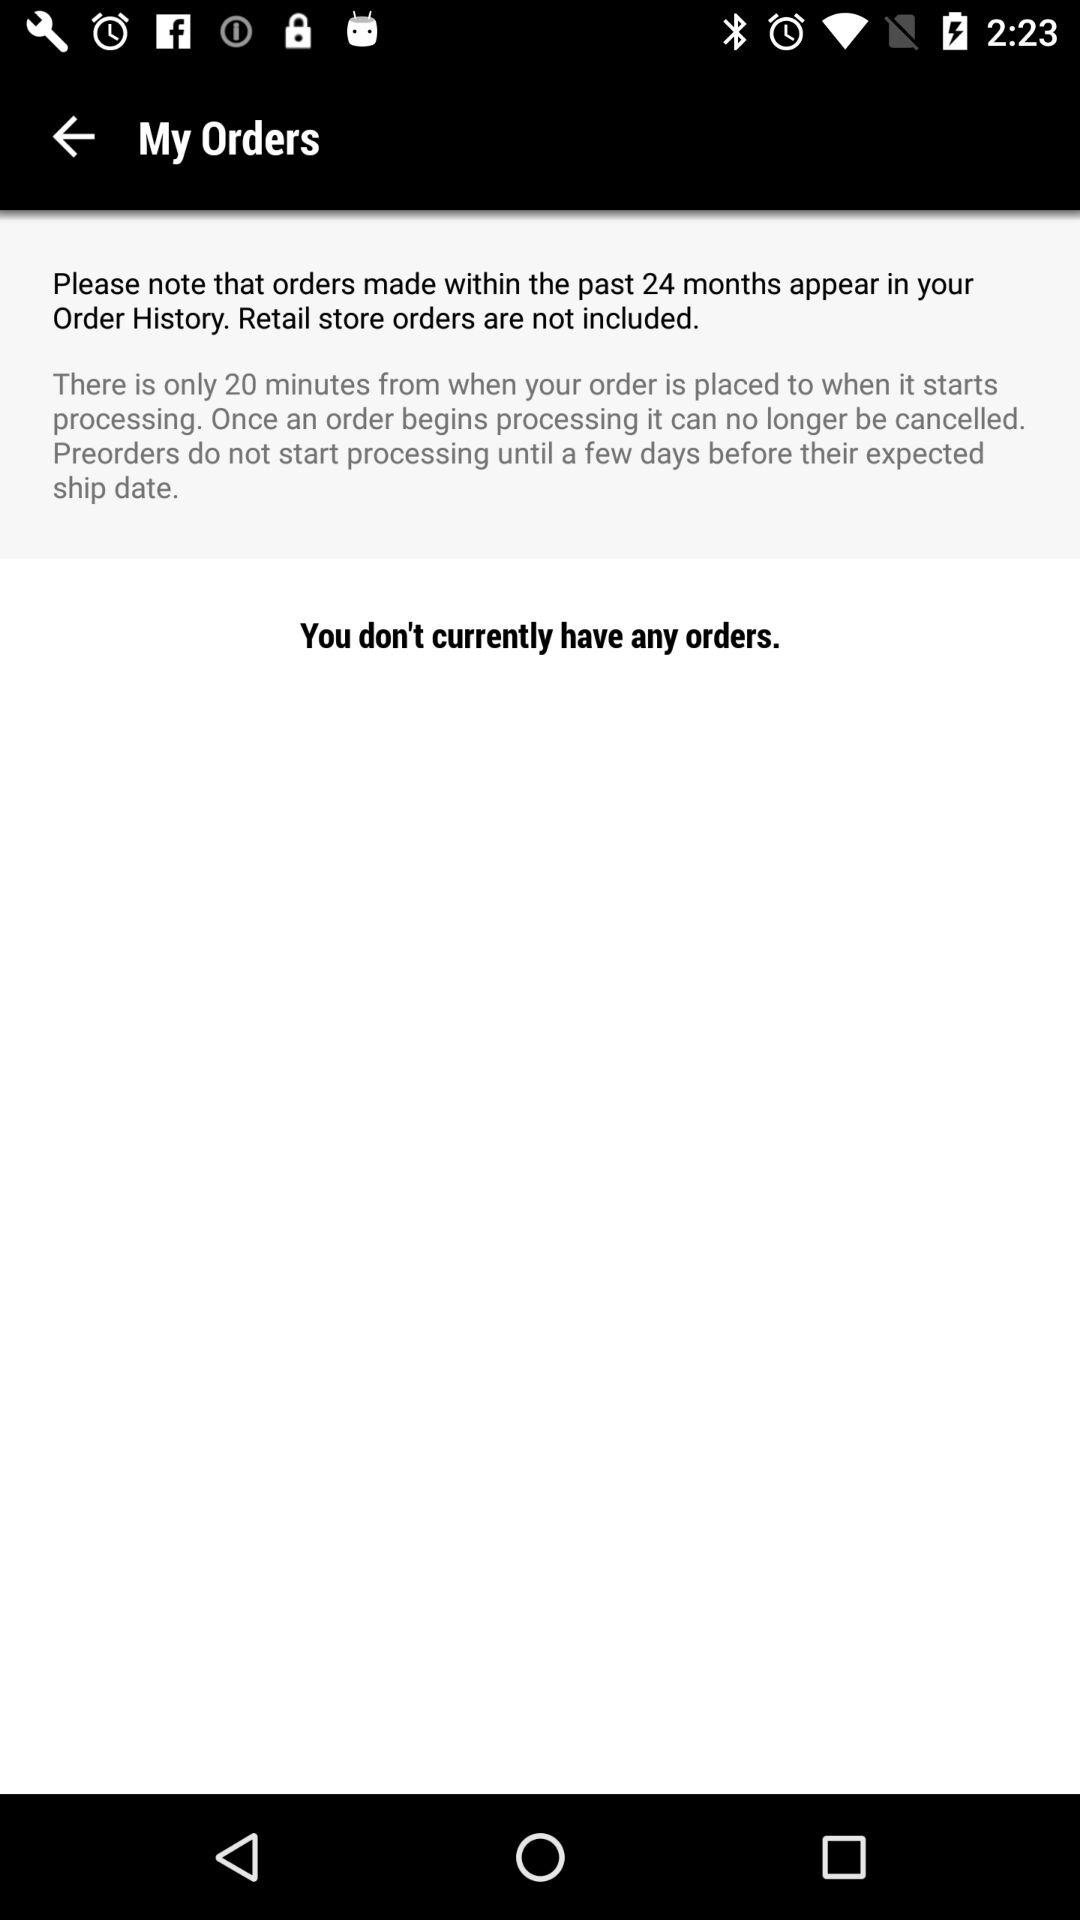How many days before an expected ship date do preorders start processing?
Answer the question using a single word or phrase. A few days 